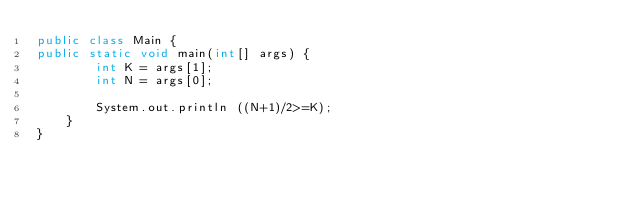Convert code to text. <code><loc_0><loc_0><loc_500><loc_500><_Java_>public class Main {
public static void main(int[] args) {
        int K = args[1];
        int N = args[0];

        System.out.println ((N+1)/2>=K);
    }
}</code> 